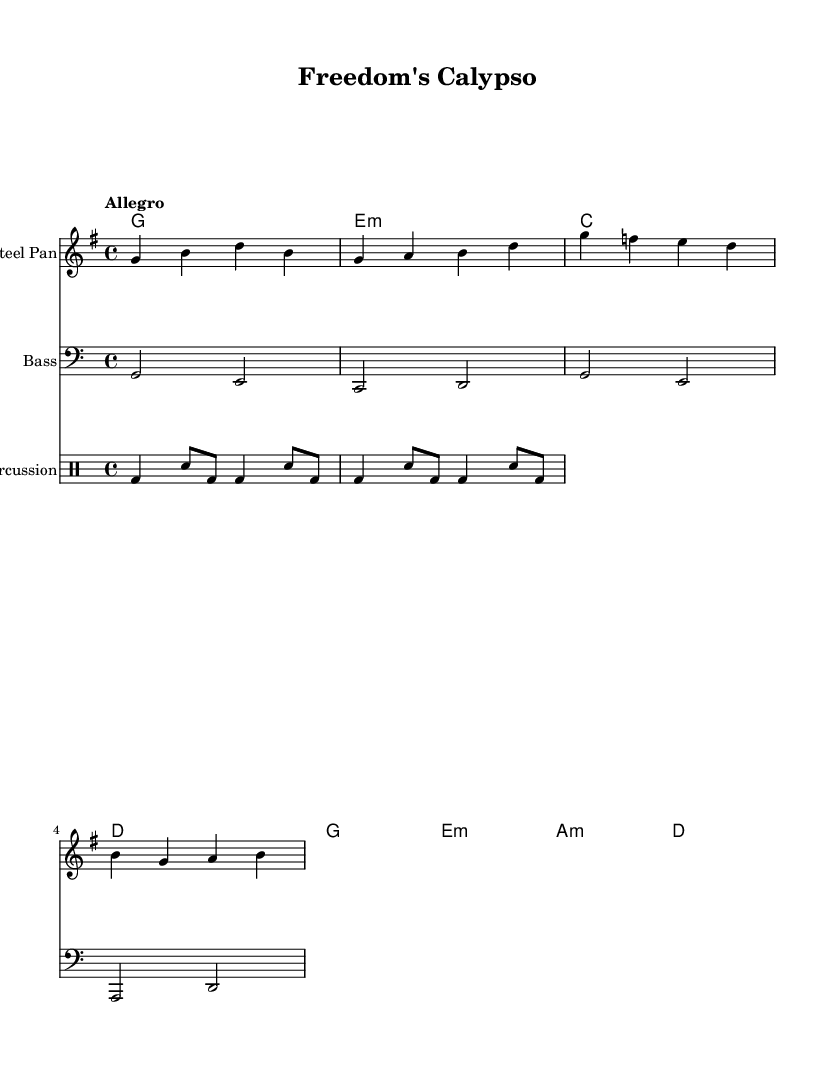What is the key signature of this music? The key signature is G major, which has one sharp (F#). You can identify this by looking at the key signature indicated at the beginning of the staff.
Answer: G major What is the time signature of this music? The time signature is 4/4, which indicates four beats per measure and a quarter note receives one beat. This can be seen in the notation placed at the beginning of the score.
Answer: 4/4 What is the tempo marking in this music? The tempo marking is "Allegro", which indicates a fast, lively pace. This is stated explicitly in the tempo indication at the beginning of the score.
Answer: Allegro How many measures are in the melody section? The melody section consists of four measures as indicated by the bar lines that separate the music into distinct segments. Counting the segments from start to finish, there are four.
Answer: 4 What is the first lyric line of the song? The first lyric line is "Rise up, people, hear the call." This can be found directly beneath the melody notes in the lyrics section of the score.
Answer: "Rise up, people, hear the call." What chords are used in the harmonies section? The chords used are G, E minor, C, D, A minor. You can determine this by looking at the chord names indicated above the staff in the harmonies section.
Answer: G, E minor, C, D, A minor What instruments are used in this score? The score features three instruments: Steel Pan, Bass, and Percussion. This is shown in the instrument names at the beginning of each staff in the score.
Answer: Steel Pan, Bass, Percussion 